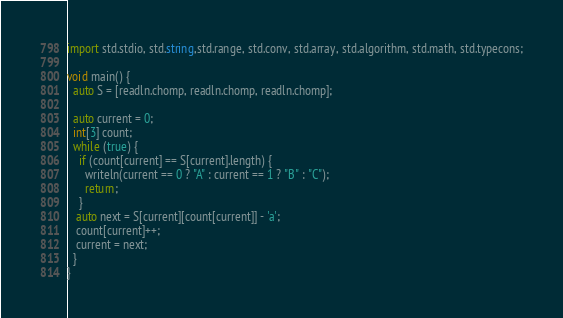Convert code to text. <code><loc_0><loc_0><loc_500><loc_500><_D_>import std.stdio, std.string,std.range, std.conv, std.array, std.algorithm, std.math, std.typecons;

void main() {
  auto S = [readln.chomp, readln.chomp, readln.chomp];

  auto current = 0;
  int[3] count;
  while (true) {
    if (count[current] == S[current].length) {
      writeln(current == 0 ? "A" : current == 1 ? "B" : "C");
      return;
    }
   auto next = S[current][count[current]] - 'a';
   count[current]++;
   current = next;
  }
}
</code> 